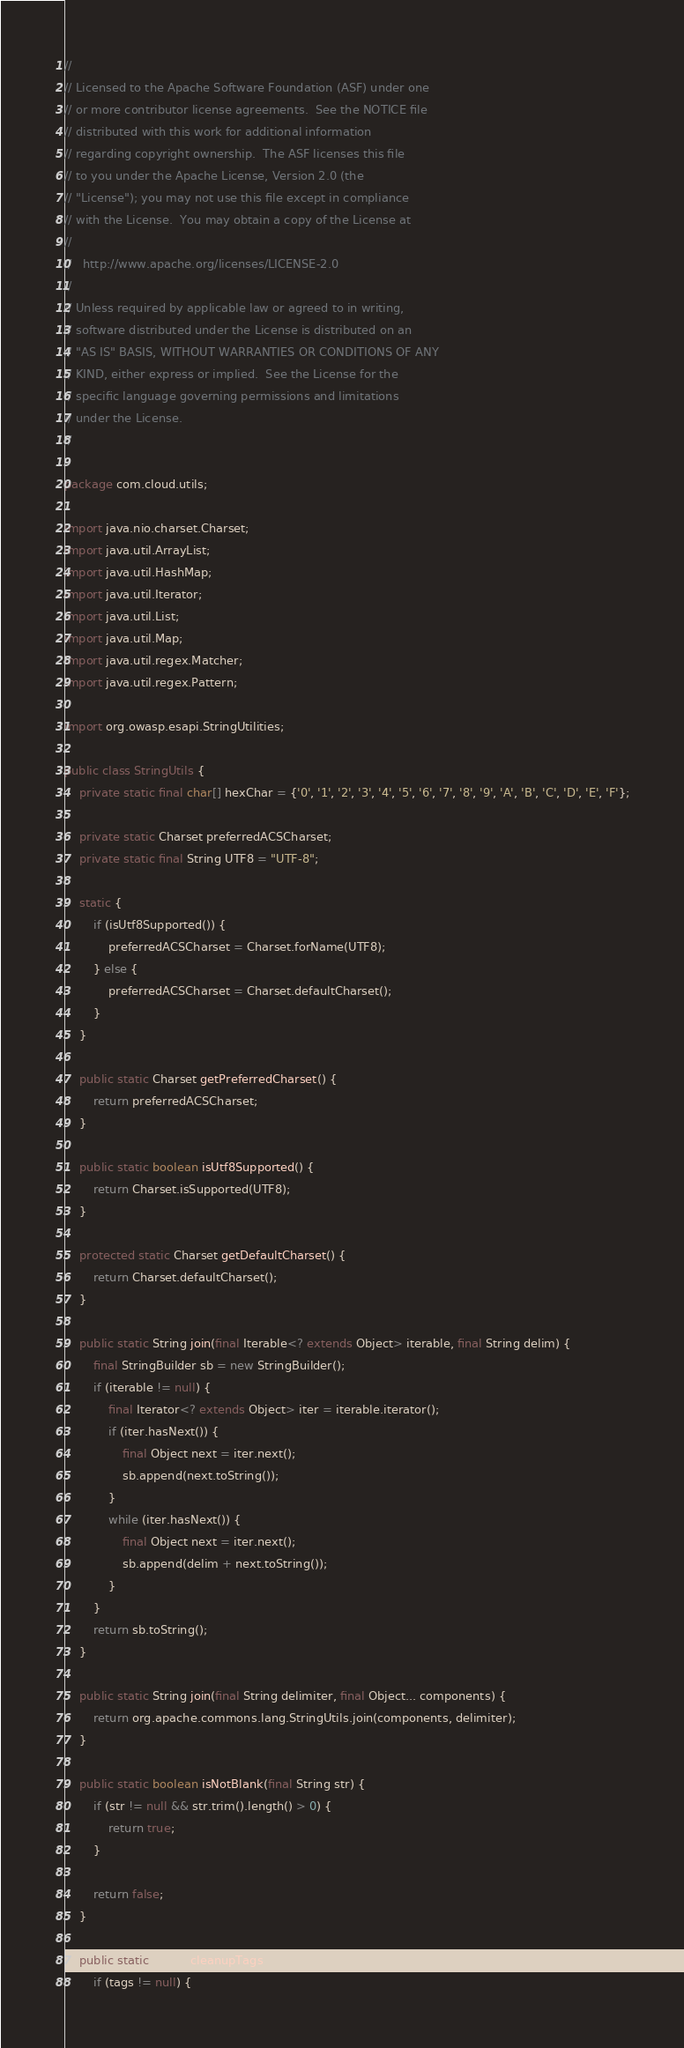Convert code to text. <code><loc_0><loc_0><loc_500><loc_500><_Java_>//
// Licensed to the Apache Software Foundation (ASF) under one
// or more contributor license agreements.  See the NOTICE file
// distributed with this work for additional information
// regarding copyright ownership.  The ASF licenses this file
// to you under the Apache License, Version 2.0 (the
// "License"); you may not use this file except in compliance
// with the License.  You may obtain a copy of the License at
//
//   http://www.apache.org/licenses/LICENSE-2.0
//
// Unless required by applicable law or agreed to in writing,
// software distributed under the License is distributed on an
// "AS IS" BASIS, WITHOUT WARRANTIES OR CONDITIONS OF ANY
// KIND, either express or implied.  See the License for the
// specific language governing permissions and limitations
// under the License.
//

package com.cloud.utils;

import java.nio.charset.Charset;
import java.util.ArrayList;
import java.util.HashMap;
import java.util.Iterator;
import java.util.List;
import java.util.Map;
import java.util.regex.Matcher;
import java.util.regex.Pattern;

import org.owasp.esapi.StringUtilities;

public class StringUtils {
    private static final char[] hexChar = {'0', '1', '2', '3', '4', '5', '6', '7', '8', '9', 'A', 'B', 'C', 'D', 'E', 'F'};

    private static Charset preferredACSCharset;
    private static final String UTF8 = "UTF-8";

    static {
        if (isUtf8Supported()) {
            preferredACSCharset = Charset.forName(UTF8);
        } else {
            preferredACSCharset = Charset.defaultCharset();
        }
    }

    public static Charset getPreferredCharset() {
        return preferredACSCharset;
    }

    public static boolean isUtf8Supported() {
        return Charset.isSupported(UTF8);
    }

    protected static Charset getDefaultCharset() {
        return Charset.defaultCharset();
    }

    public static String join(final Iterable<? extends Object> iterable, final String delim) {
        final StringBuilder sb = new StringBuilder();
        if (iterable != null) {
            final Iterator<? extends Object> iter = iterable.iterator();
            if (iter.hasNext()) {
                final Object next = iter.next();
                sb.append(next.toString());
            }
            while (iter.hasNext()) {
                final Object next = iter.next();
                sb.append(delim + next.toString());
            }
        }
        return sb.toString();
    }

    public static String join(final String delimiter, final Object... components) {
        return org.apache.commons.lang.StringUtils.join(components, delimiter);
    }

    public static boolean isNotBlank(final String str) {
        if (str != null && str.trim().length() > 0) {
            return true;
        }

        return false;
    }

    public static String cleanupTags(String tags) {
        if (tags != null) {</code> 